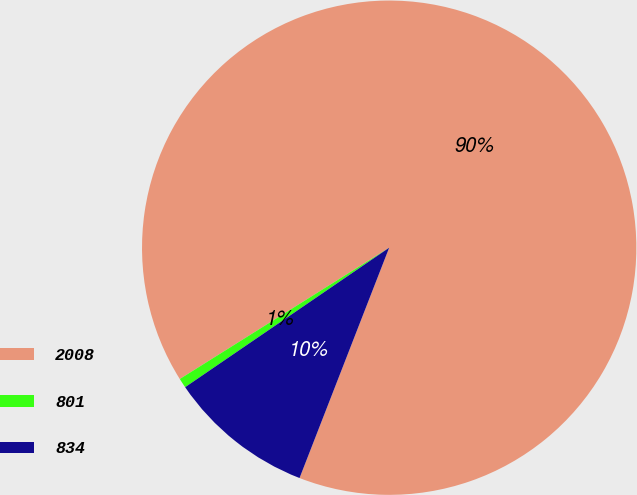Convert chart. <chart><loc_0><loc_0><loc_500><loc_500><pie_chart><fcel>2008<fcel>801<fcel>834<nl><fcel>89.83%<fcel>0.63%<fcel>9.55%<nl></chart> 